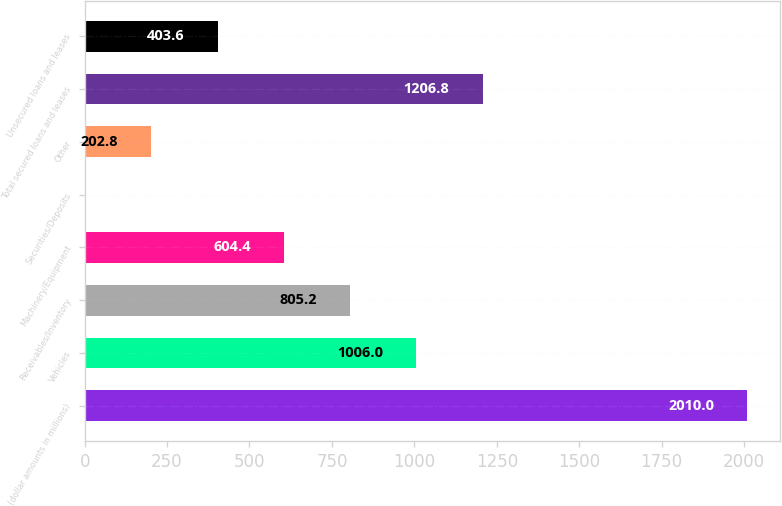<chart> <loc_0><loc_0><loc_500><loc_500><bar_chart><fcel>(dollar amounts in millions)<fcel>Vehicles<fcel>Receivables/Inventory<fcel>Machinery/Equipment<fcel>Securities/Deposits<fcel>Other<fcel>Total secured loans and leases<fcel>Unsecured loans and leases<nl><fcel>2010<fcel>1006<fcel>805.2<fcel>604.4<fcel>2<fcel>202.8<fcel>1206.8<fcel>403.6<nl></chart> 